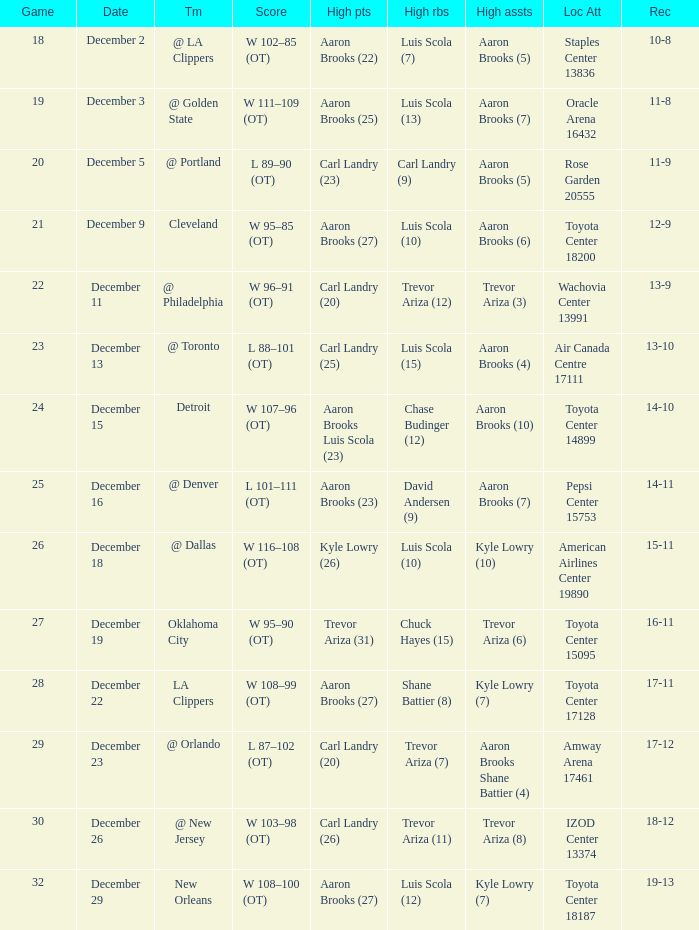Where was the game in which Carl Landry (25) did the most high points played? Air Canada Centre 17111. 